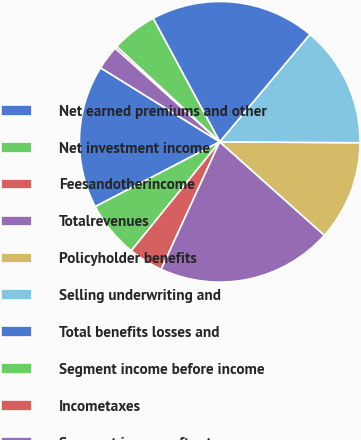Convert chart. <chart><loc_0><loc_0><loc_500><loc_500><pie_chart><fcel>Net earned premiums and other<fcel>Net investment income<fcel>Feesandotherincome<fcel>Totalrevenues<fcel>Policyholder benefits<fcel>Selling underwriting and<fcel>Total benefits losses and<fcel>Segment income before income<fcel>Incometaxes<fcel>Segment income after tax<nl><fcel>16.49%<fcel>6.5%<fcel>4.01%<fcel>20.24%<fcel>11.5%<fcel>13.99%<fcel>18.99%<fcel>5.26%<fcel>0.26%<fcel>2.76%<nl></chart> 